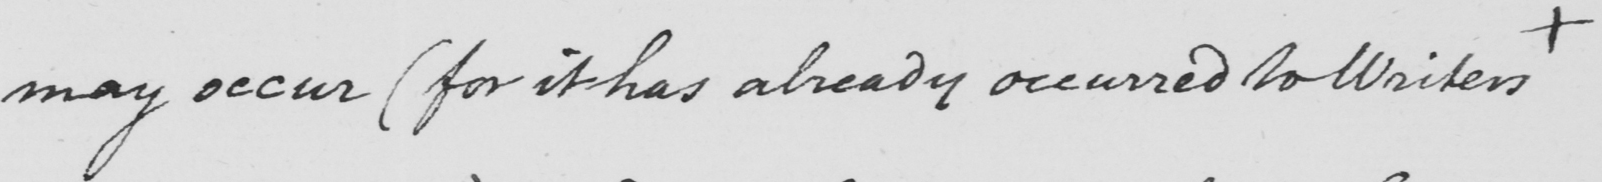What text is written in this handwritten line? may occur  ( for it has already occurred to Writers  + 